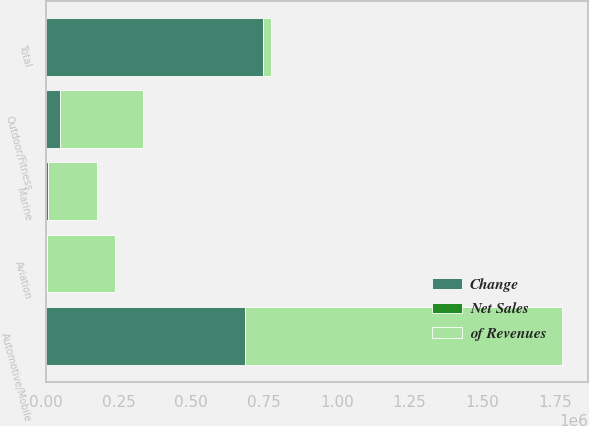<chart> <loc_0><loc_0><loc_500><loc_500><stacked_bar_chart><ecel><fcel>Outdoor/Fitness<fcel>Marine<fcel>Automotive/Mobile<fcel>Aviation<fcel>Total<nl><fcel>of Revenues<fcel>285362<fcel>166639<fcel>1.08909e+06<fcel>232906<fcel>28401.5<nl><fcel>Net Sales<fcel>16.1<fcel>9.4<fcel>61.4<fcel>13.1<fcel>100<nl><fcel>Change<fcel>48426<fcel>8377<fcel>685676<fcel>3748<fcel>746227<nl></chart> 